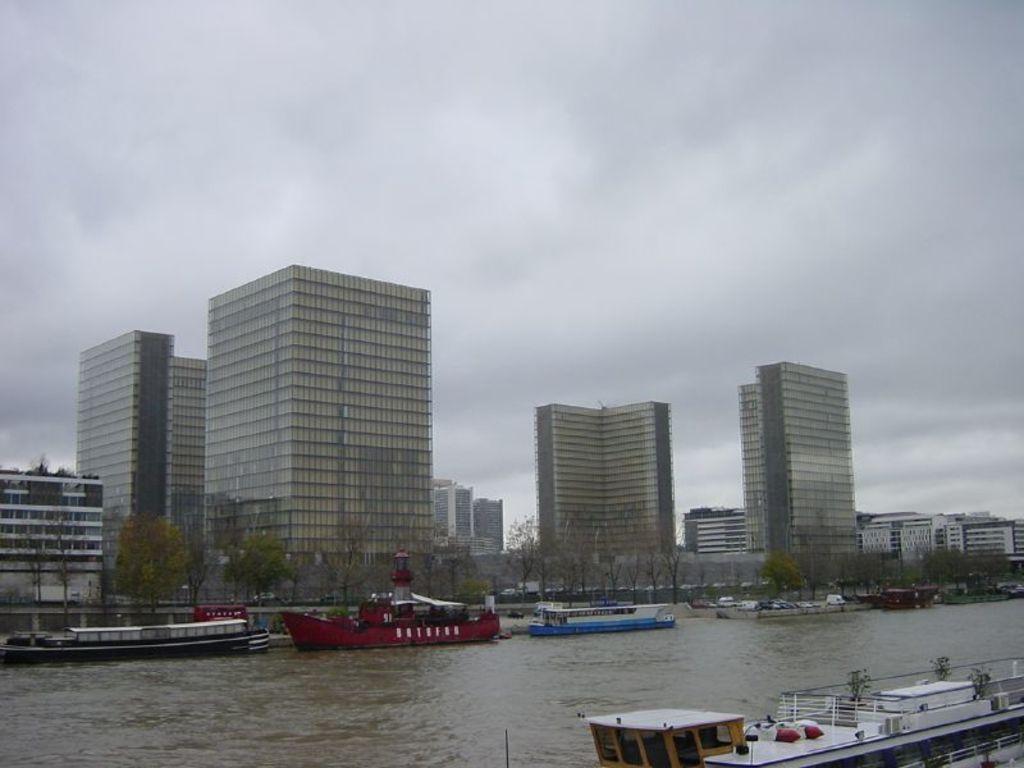How would you summarize this image in a sentence or two? In this image we can see some boats on the water, there are some trees, plants and buildings, in the background we can see the sky. 